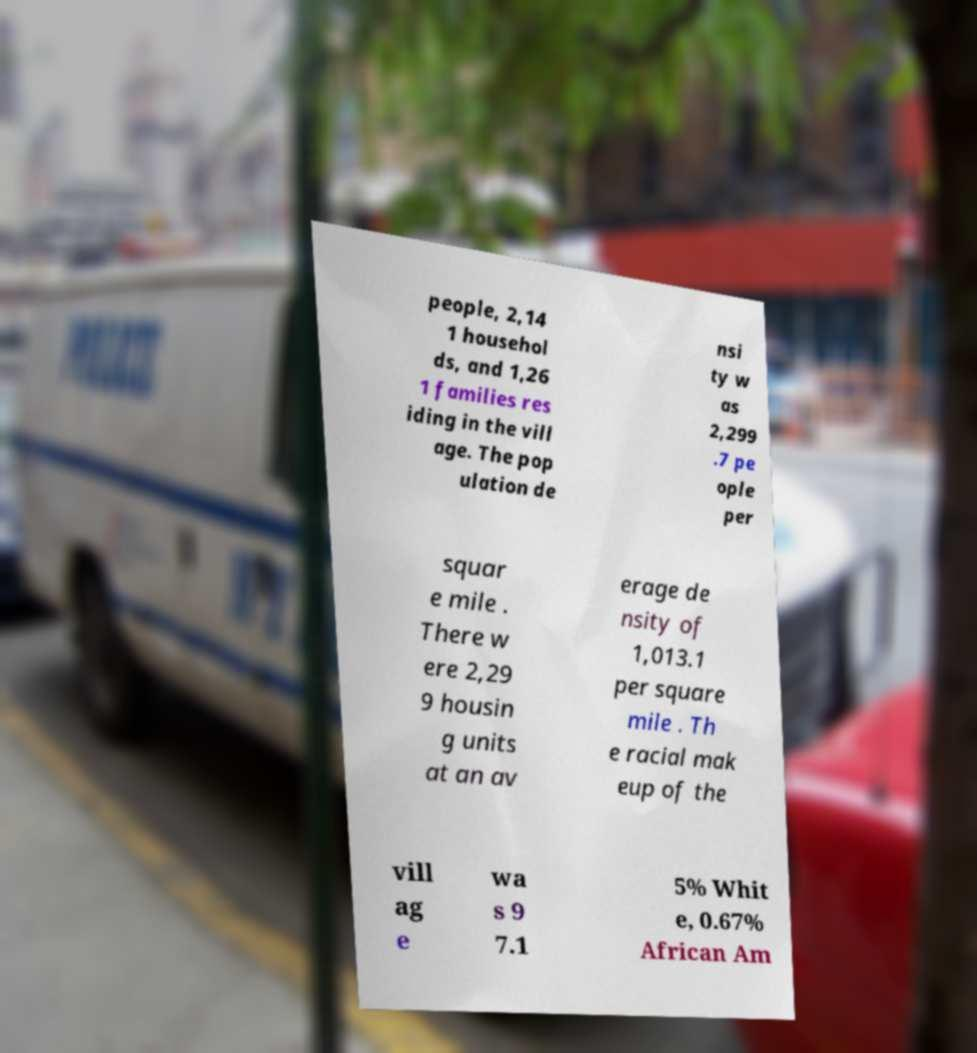Please identify and transcribe the text found in this image. people, 2,14 1 househol ds, and 1,26 1 families res iding in the vill age. The pop ulation de nsi ty w as 2,299 .7 pe ople per squar e mile . There w ere 2,29 9 housin g units at an av erage de nsity of 1,013.1 per square mile . Th e racial mak eup of the vill ag e wa s 9 7.1 5% Whit e, 0.67% African Am 